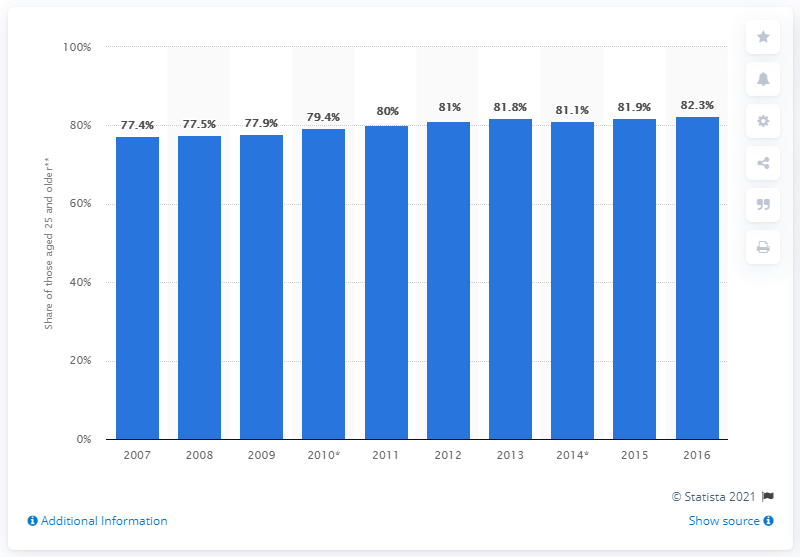Draw attention to some important aspects in this diagram. In 2016, 82.3% of Bulgarians aged 25 and over had attained a higher secondary or tertiary education. 